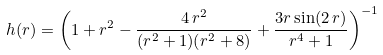<formula> <loc_0><loc_0><loc_500><loc_500>h ( r ) = \left ( 1 + r ^ { 2 } - \frac { 4 \, r ^ { 2 } } { ( r ^ { 2 } + 1 ) ( r ^ { 2 } + 8 ) } + \frac { 3 r \sin ( 2 \, r ) } { r ^ { 4 } + 1 } \right ) ^ { - 1 }</formula> 